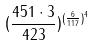<formula> <loc_0><loc_0><loc_500><loc_500>( \frac { 4 5 1 \cdot 3 } { 4 2 3 } ) ^ { ( \frac { 6 } { 1 1 7 } ) ^ { 4 } }</formula> 